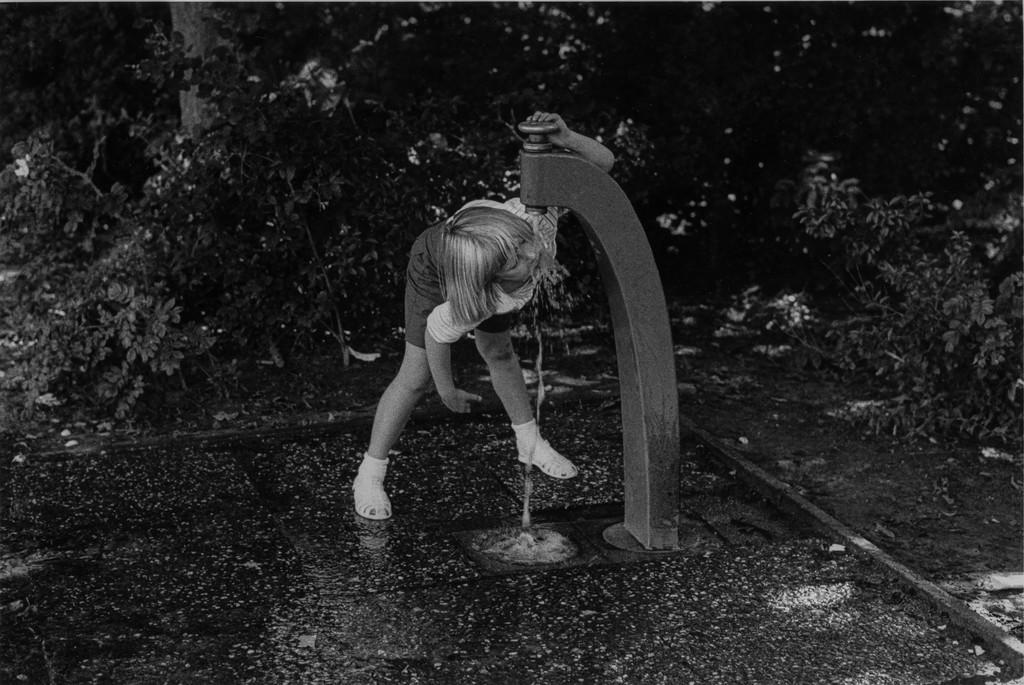Who is the main subject in the image? There is a girl in the image. What is the girl doing in the image? The girl is drinking water. What is the source of water in the image? There is a tap in front of the girl. What can be seen in the background of the image? There are trees in the background of the image. How is the image presented in terms of color? The image is in black and white. What type of powder is being used by the girl in the image? There is no powder present in the image; the girl is drinking water from a tap. 